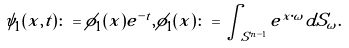Convert formula to latex. <formula><loc_0><loc_0><loc_500><loc_500>\psi _ { 1 } ( x , t ) \colon = \phi _ { 1 } ( x ) e ^ { - t } , \phi _ { 1 } ( x ) \colon = \int _ { S ^ { n - 1 } } e ^ { x \cdot \omega } d S _ { \omega } .</formula> 